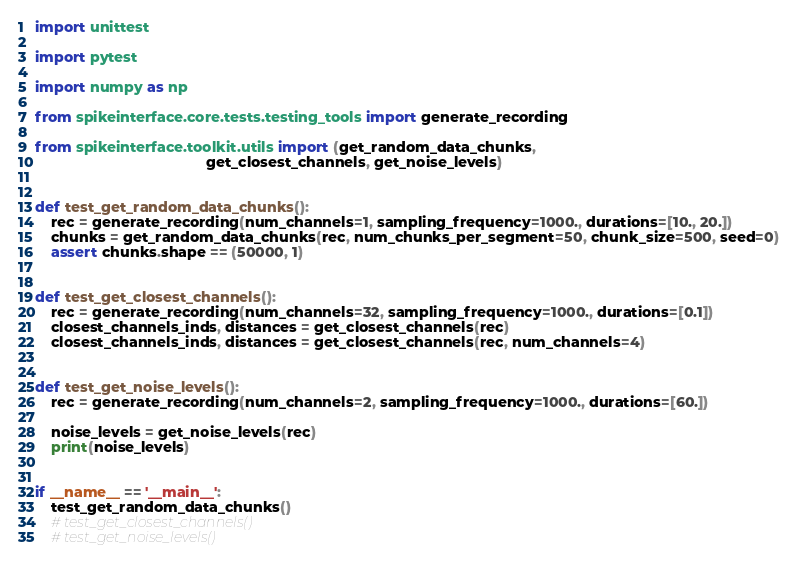<code> <loc_0><loc_0><loc_500><loc_500><_Python_>import unittest

import pytest

import numpy as np

from spikeinterface.core.tests.testing_tools import generate_recording

from spikeinterface.toolkit.utils import (get_random_data_chunks,
                                          get_closest_channels, get_noise_levels)


def test_get_random_data_chunks():
    rec = generate_recording(num_channels=1, sampling_frequency=1000., durations=[10., 20.])
    chunks = get_random_data_chunks(rec, num_chunks_per_segment=50, chunk_size=500, seed=0)
    assert chunks.shape == (50000, 1)


def test_get_closest_channels():
    rec = generate_recording(num_channels=32, sampling_frequency=1000., durations=[0.1])
    closest_channels_inds, distances = get_closest_channels(rec)
    closest_channels_inds, distances = get_closest_channels(rec, num_channels=4)


def test_get_noise_levels():
    rec = generate_recording(num_channels=2, sampling_frequency=1000., durations=[60.])

    noise_levels = get_noise_levels(rec)
    print(noise_levels)


if __name__ == '__main__':
    test_get_random_data_chunks()
    # test_get_closest_channels()
    # test_get_noise_levels()
</code> 